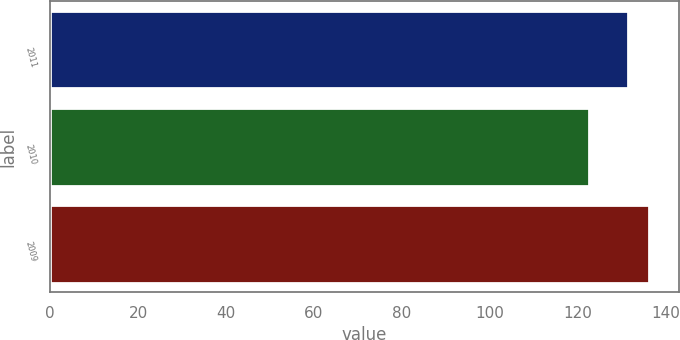Convert chart. <chart><loc_0><loc_0><loc_500><loc_500><bar_chart><fcel>2011<fcel>2010<fcel>2009<nl><fcel>131.5<fcel>122.7<fcel>136.3<nl></chart> 